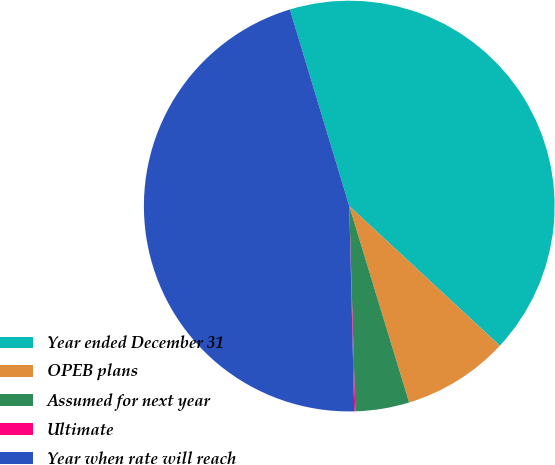Convert chart to OTSL. <chart><loc_0><loc_0><loc_500><loc_500><pie_chart><fcel>Year ended December 31<fcel>OPEB plans<fcel>Assumed for next year<fcel>Ultimate<fcel>Year when rate will reach<nl><fcel>41.57%<fcel>8.39%<fcel>4.24%<fcel>0.08%<fcel>45.72%<nl></chart> 